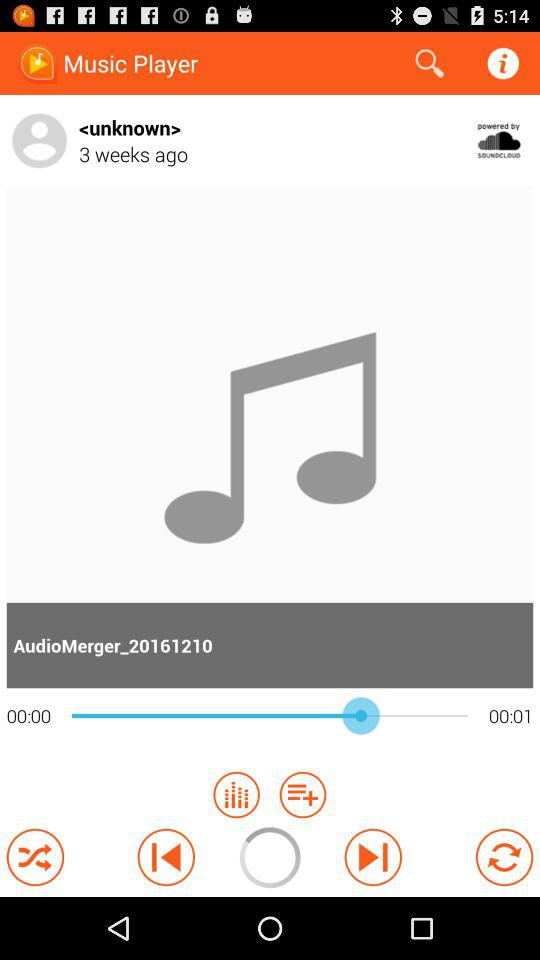What is the name of the current audio? The name of the current audio is AudioMerger_20161210. 